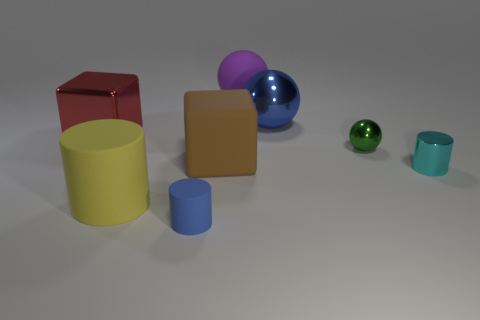Can you tell me the number of geometric shapes present in the image? Certainly, the image features a total of seven geometric shapes: There are two cubes, two cylinders, and three spheres.  Are all of the objects in the image solid, or are any of them hollow or contain empty space? From the provided angle, it's not possible to conclusively determine if any of the objects are hollow. However, based on common rendering practices, they are often modeled as solid for simplicity, unless the object's interior is of particular interest or importance. 